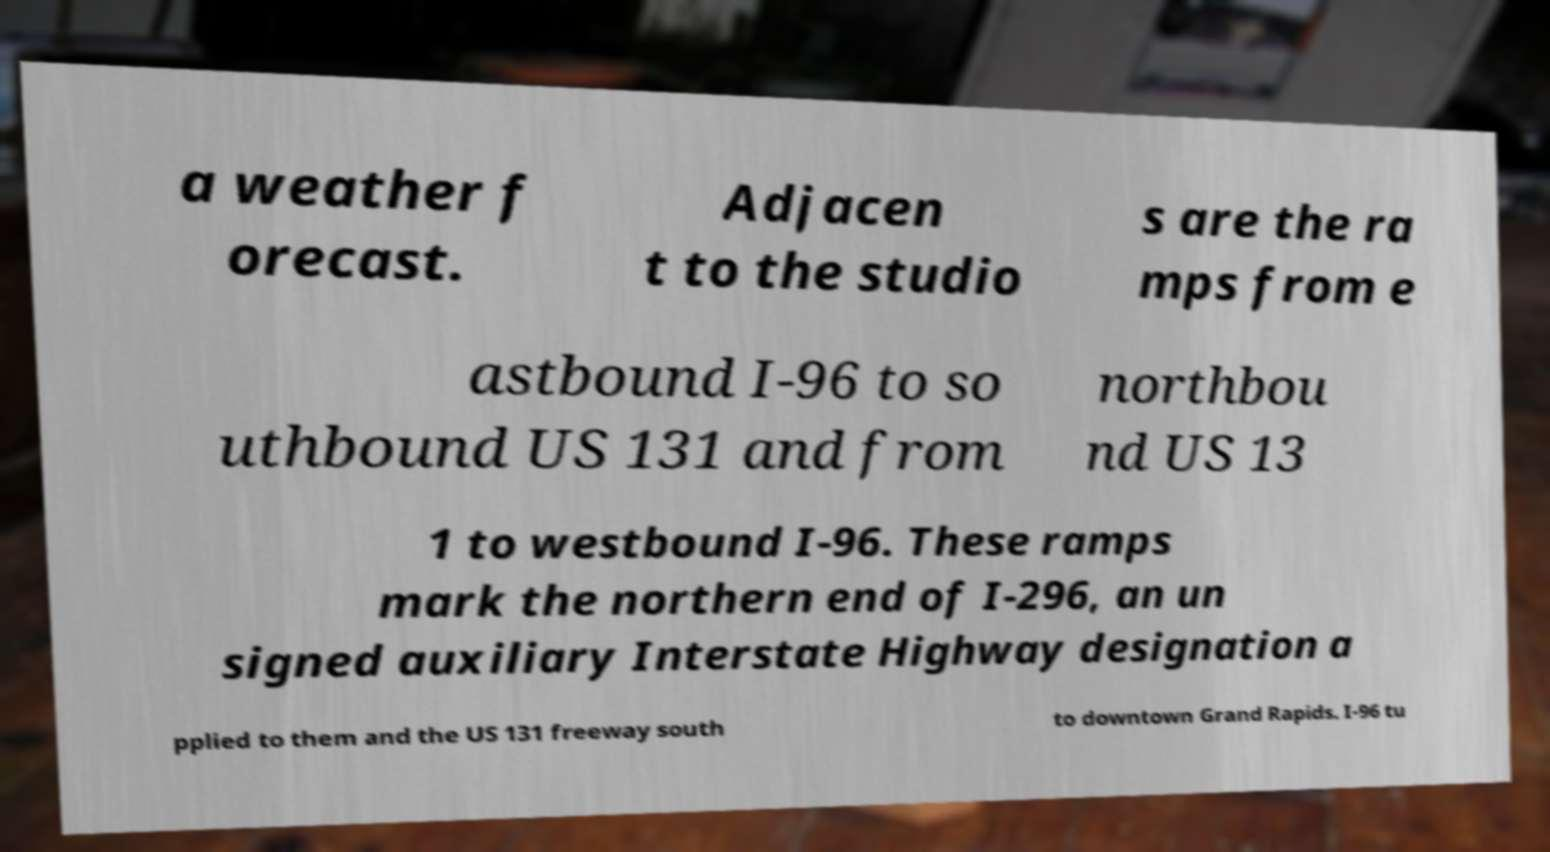Could you assist in decoding the text presented in this image and type it out clearly? a weather f orecast. Adjacen t to the studio s are the ra mps from e astbound I-96 to so uthbound US 131 and from northbou nd US 13 1 to westbound I-96. These ramps mark the northern end of I-296, an un signed auxiliary Interstate Highway designation a pplied to them and the US 131 freeway south to downtown Grand Rapids. I-96 tu 